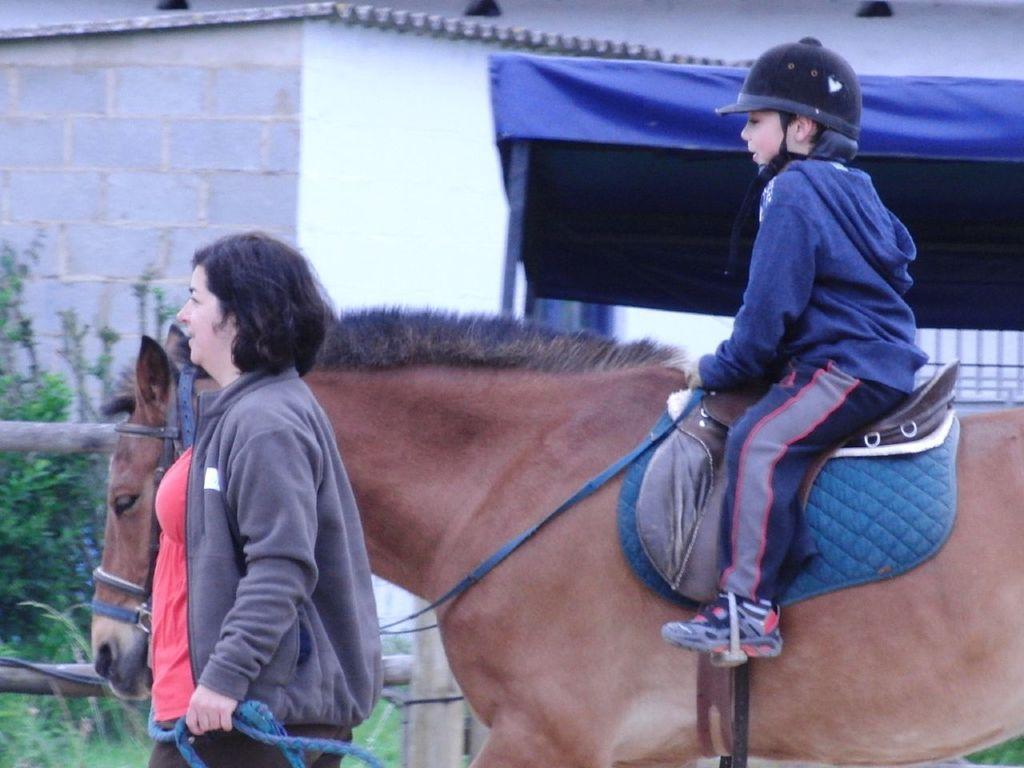Please provide a concise description of this image. In this image there is a boy sitting on the horse by wearing the helmet and sweater. On the left side there is a woman walking on the ground by holding the belt which is tied to the horse. In the background there is a house. On the right side there is a tent. At the bottom there are plants beside the fence. 